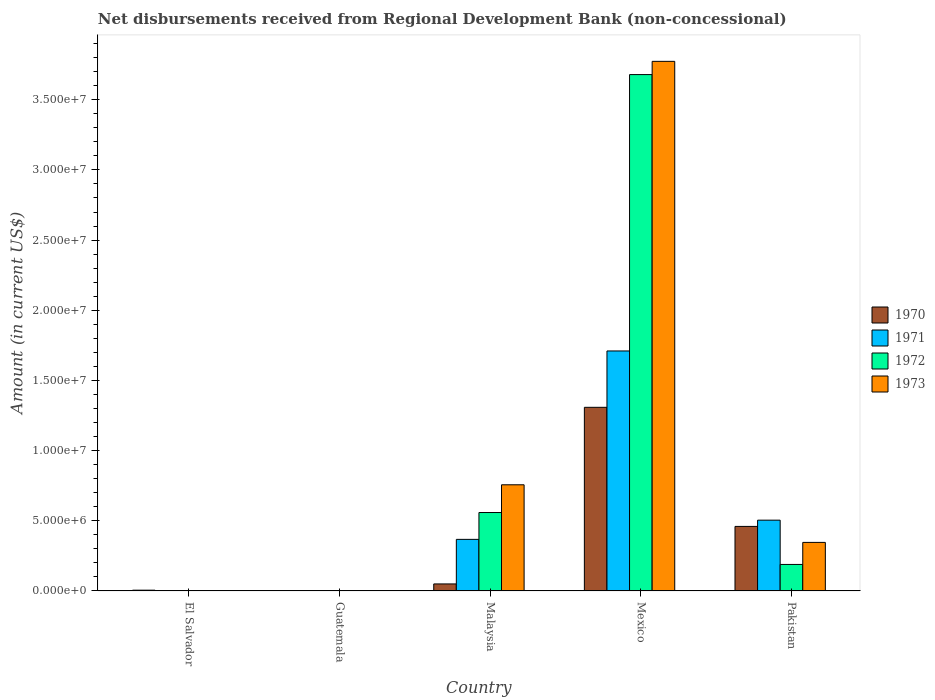Are the number of bars per tick equal to the number of legend labels?
Your answer should be very brief. No. Are the number of bars on each tick of the X-axis equal?
Provide a succinct answer. No. What is the label of the 3rd group of bars from the left?
Your answer should be very brief. Malaysia. What is the amount of disbursements received from Regional Development Bank in 1971 in Pakistan?
Your answer should be compact. 5.04e+06. Across all countries, what is the maximum amount of disbursements received from Regional Development Bank in 1973?
Offer a very short reply. 3.77e+07. Across all countries, what is the minimum amount of disbursements received from Regional Development Bank in 1971?
Make the answer very short. 0. In which country was the amount of disbursements received from Regional Development Bank in 1971 maximum?
Keep it short and to the point. Mexico. What is the total amount of disbursements received from Regional Development Bank in 1972 in the graph?
Offer a terse response. 4.43e+07. What is the difference between the amount of disbursements received from Regional Development Bank in 1970 in Malaysia and that in Mexico?
Ensure brevity in your answer.  -1.26e+07. What is the difference between the amount of disbursements received from Regional Development Bank in 1973 in Malaysia and the amount of disbursements received from Regional Development Bank in 1971 in Mexico?
Your answer should be compact. -9.54e+06. What is the average amount of disbursements received from Regional Development Bank in 1972 per country?
Your answer should be compact. 8.85e+06. What is the difference between the amount of disbursements received from Regional Development Bank of/in 1971 and amount of disbursements received from Regional Development Bank of/in 1973 in Pakistan?
Provide a succinct answer. 1.58e+06. In how many countries, is the amount of disbursements received from Regional Development Bank in 1973 greater than 12000000 US$?
Offer a very short reply. 1. What is the ratio of the amount of disbursements received from Regional Development Bank in 1971 in Malaysia to that in Mexico?
Offer a very short reply. 0.22. What is the difference between the highest and the second highest amount of disbursements received from Regional Development Bank in 1973?
Ensure brevity in your answer.  3.43e+07. What is the difference between the highest and the lowest amount of disbursements received from Regional Development Bank in 1973?
Ensure brevity in your answer.  3.77e+07. Is the sum of the amount of disbursements received from Regional Development Bank in 1973 in Malaysia and Pakistan greater than the maximum amount of disbursements received from Regional Development Bank in 1972 across all countries?
Make the answer very short. No. Is it the case that in every country, the sum of the amount of disbursements received from Regional Development Bank in 1973 and amount of disbursements received from Regional Development Bank in 1970 is greater than the sum of amount of disbursements received from Regional Development Bank in 1972 and amount of disbursements received from Regional Development Bank in 1971?
Offer a terse response. No. Is it the case that in every country, the sum of the amount of disbursements received from Regional Development Bank in 1970 and amount of disbursements received from Regional Development Bank in 1971 is greater than the amount of disbursements received from Regional Development Bank in 1972?
Offer a terse response. No. How many bars are there?
Keep it short and to the point. 13. How many countries are there in the graph?
Ensure brevity in your answer.  5. What is the difference between two consecutive major ticks on the Y-axis?
Provide a short and direct response. 5.00e+06. Does the graph contain grids?
Offer a terse response. No. Where does the legend appear in the graph?
Your answer should be compact. Center right. How many legend labels are there?
Offer a terse response. 4. What is the title of the graph?
Keep it short and to the point. Net disbursements received from Regional Development Bank (non-concessional). Does "2010" appear as one of the legend labels in the graph?
Ensure brevity in your answer.  No. What is the Amount (in current US$) of 1970 in El Salvador?
Offer a very short reply. 5.70e+04. What is the Amount (in current US$) of 1970 in Guatemala?
Make the answer very short. 0. What is the Amount (in current US$) in 1971 in Guatemala?
Provide a succinct answer. 0. What is the Amount (in current US$) in 1970 in Malaysia?
Your response must be concise. 5.02e+05. What is the Amount (in current US$) in 1971 in Malaysia?
Keep it short and to the point. 3.68e+06. What is the Amount (in current US$) of 1972 in Malaysia?
Make the answer very short. 5.59e+06. What is the Amount (in current US$) in 1973 in Malaysia?
Make the answer very short. 7.57e+06. What is the Amount (in current US$) of 1970 in Mexico?
Your response must be concise. 1.31e+07. What is the Amount (in current US$) of 1971 in Mexico?
Offer a very short reply. 1.71e+07. What is the Amount (in current US$) in 1972 in Mexico?
Give a very brief answer. 3.68e+07. What is the Amount (in current US$) of 1973 in Mexico?
Ensure brevity in your answer.  3.77e+07. What is the Amount (in current US$) in 1970 in Pakistan?
Your answer should be compact. 4.60e+06. What is the Amount (in current US$) of 1971 in Pakistan?
Ensure brevity in your answer.  5.04e+06. What is the Amount (in current US$) of 1972 in Pakistan?
Provide a succinct answer. 1.89e+06. What is the Amount (in current US$) in 1973 in Pakistan?
Offer a terse response. 3.46e+06. Across all countries, what is the maximum Amount (in current US$) of 1970?
Your answer should be compact. 1.31e+07. Across all countries, what is the maximum Amount (in current US$) of 1971?
Keep it short and to the point. 1.71e+07. Across all countries, what is the maximum Amount (in current US$) of 1972?
Keep it short and to the point. 3.68e+07. Across all countries, what is the maximum Amount (in current US$) in 1973?
Offer a terse response. 3.77e+07. Across all countries, what is the minimum Amount (in current US$) in 1971?
Your response must be concise. 0. What is the total Amount (in current US$) in 1970 in the graph?
Make the answer very short. 1.82e+07. What is the total Amount (in current US$) in 1971 in the graph?
Your answer should be compact. 2.58e+07. What is the total Amount (in current US$) of 1972 in the graph?
Provide a short and direct response. 4.43e+07. What is the total Amount (in current US$) of 1973 in the graph?
Ensure brevity in your answer.  4.88e+07. What is the difference between the Amount (in current US$) of 1970 in El Salvador and that in Malaysia?
Your response must be concise. -4.45e+05. What is the difference between the Amount (in current US$) in 1970 in El Salvador and that in Mexico?
Give a very brief answer. -1.30e+07. What is the difference between the Amount (in current US$) in 1970 in El Salvador and that in Pakistan?
Ensure brevity in your answer.  -4.54e+06. What is the difference between the Amount (in current US$) in 1970 in Malaysia and that in Mexico?
Ensure brevity in your answer.  -1.26e+07. What is the difference between the Amount (in current US$) of 1971 in Malaysia and that in Mexico?
Ensure brevity in your answer.  -1.34e+07. What is the difference between the Amount (in current US$) in 1972 in Malaysia and that in Mexico?
Provide a short and direct response. -3.12e+07. What is the difference between the Amount (in current US$) of 1973 in Malaysia and that in Mexico?
Ensure brevity in your answer.  -3.02e+07. What is the difference between the Amount (in current US$) of 1970 in Malaysia and that in Pakistan?
Your answer should be very brief. -4.10e+06. What is the difference between the Amount (in current US$) of 1971 in Malaysia and that in Pakistan?
Provide a short and direct response. -1.37e+06. What is the difference between the Amount (in current US$) of 1972 in Malaysia and that in Pakistan?
Offer a terse response. 3.70e+06. What is the difference between the Amount (in current US$) in 1973 in Malaysia and that in Pakistan?
Make the answer very short. 4.10e+06. What is the difference between the Amount (in current US$) in 1970 in Mexico and that in Pakistan?
Provide a short and direct response. 8.48e+06. What is the difference between the Amount (in current US$) in 1971 in Mexico and that in Pakistan?
Provide a succinct answer. 1.21e+07. What is the difference between the Amount (in current US$) in 1972 in Mexico and that in Pakistan?
Keep it short and to the point. 3.49e+07. What is the difference between the Amount (in current US$) of 1973 in Mexico and that in Pakistan?
Offer a very short reply. 3.43e+07. What is the difference between the Amount (in current US$) in 1970 in El Salvador and the Amount (in current US$) in 1971 in Malaysia?
Provide a short and direct response. -3.62e+06. What is the difference between the Amount (in current US$) in 1970 in El Salvador and the Amount (in current US$) in 1972 in Malaysia?
Your answer should be compact. -5.53e+06. What is the difference between the Amount (in current US$) in 1970 in El Salvador and the Amount (in current US$) in 1973 in Malaysia?
Offer a terse response. -7.51e+06. What is the difference between the Amount (in current US$) in 1970 in El Salvador and the Amount (in current US$) in 1971 in Mexico?
Ensure brevity in your answer.  -1.70e+07. What is the difference between the Amount (in current US$) of 1970 in El Salvador and the Amount (in current US$) of 1972 in Mexico?
Provide a short and direct response. -3.67e+07. What is the difference between the Amount (in current US$) of 1970 in El Salvador and the Amount (in current US$) of 1973 in Mexico?
Keep it short and to the point. -3.77e+07. What is the difference between the Amount (in current US$) in 1970 in El Salvador and the Amount (in current US$) in 1971 in Pakistan?
Ensure brevity in your answer.  -4.99e+06. What is the difference between the Amount (in current US$) of 1970 in El Salvador and the Amount (in current US$) of 1972 in Pakistan?
Provide a succinct answer. -1.83e+06. What is the difference between the Amount (in current US$) in 1970 in El Salvador and the Amount (in current US$) in 1973 in Pakistan?
Make the answer very short. -3.40e+06. What is the difference between the Amount (in current US$) in 1970 in Malaysia and the Amount (in current US$) in 1971 in Mexico?
Provide a short and direct response. -1.66e+07. What is the difference between the Amount (in current US$) in 1970 in Malaysia and the Amount (in current US$) in 1972 in Mexico?
Your answer should be compact. -3.63e+07. What is the difference between the Amount (in current US$) in 1970 in Malaysia and the Amount (in current US$) in 1973 in Mexico?
Provide a succinct answer. -3.72e+07. What is the difference between the Amount (in current US$) of 1971 in Malaysia and the Amount (in current US$) of 1972 in Mexico?
Your answer should be compact. -3.31e+07. What is the difference between the Amount (in current US$) of 1971 in Malaysia and the Amount (in current US$) of 1973 in Mexico?
Give a very brief answer. -3.41e+07. What is the difference between the Amount (in current US$) in 1972 in Malaysia and the Amount (in current US$) in 1973 in Mexico?
Offer a very short reply. -3.21e+07. What is the difference between the Amount (in current US$) in 1970 in Malaysia and the Amount (in current US$) in 1971 in Pakistan?
Provide a short and direct response. -4.54e+06. What is the difference between the Amount (in current US$) of 1970 in Malaysia and the Amount (in current US$) of 1972 in Pakistan?
Your answer should be compact. -1.39e+06. What is the difference between the Amount (in current US$) in 1970 in Malaysia and the Amount (in current US$) in 1973 in Pakistan?
Make the answer very short. -2.96e+06. What is the difference between the Amount (in current US$) of 1971 in Malaysia and the Amount (in current US$) of 1972 in Pakistan?
Provide a succinct answer. 1.79e+06. What is the difference between the Amount (in current US$) of 1971 in Malaysia and the Amount (in current US$) of 1973 in Pakistan?
Ensure brevity in your answer.  2.16e+05. What is the difference between the Amount (in current US$) of 1972 in Malaysia and the Amount (in current US$) of 1973 in Pakistan?
Your response must be concise. 2.13e+06. What is the difference between the Amount (in current US$) of 1970 in Mexico and the Amount (in current US$) of 1971 in Pakistan?
Make the answer very short. 8.04e+06. What is the difference between the Amount (in current US$) of 1970 in Mexico and the Amount (in current US$) of 1972 in Pakistan?
Offer a very short reply. 1.12e+07. What is the difference between the Amount (in current US$) of 1970 in Mexico and the Amount (in current US$) of 1973 in Pakistan?
Give a very brief answer. 9.62e+06. What is the difference between the Amount (in current US$) in 1971 in Mexico and the Amount (in current US$) in 1972 in Pakistan?
Make the answer very short. 1.52e+07. What is the difference between the Amount (in current US$) in 1971 in Mexico and the Amount (in current US$) in 1973 in Pakistan?
Your response must be concise. 1.36e+07. What is the difference between the Amount (in current US$) in 1972 in Mexico and the Amount (in current US$) in 1973 in Pakistan?
Give a very brief answer. 3.33e+07. What is the average Amount (in current US$) in 1970 per country?
Provide a short and direct response. 3.65e+06. What is the average Amount (in current US$) in 1971 per country?
Offer a very short reply. 5.16e+06. What is the average Amount (in current US$) of 1972 per country?
Your answer should be very brief. 8.85e+06. What is the average Amount (in current US$) in 1973 per country?
Give a very brief answer. 9.75e+06. What is the difference between the Amount (in current US$) of 1970 and Amount (in current US$) of 1971 in Malaysia?
Keep it short and to the point. -3.18e+06. What is the difference between the Amount (in current US$) in 1970 and Amount (in current US$) in 1972 in Malaysia?
Keep it short and to the point. -5.09e+06. What is the difference between the Amount (in current US$) in 1970 and Amount (in current US$) in 1973 in Malaysia?
Offer a terse response. -7.06e+06. What is the difference between the Amount (in current US$) in 1971 and Amount (in current US$) in 1972 in Malaysia?
Give a very brief answer. -1.91e+06. What is the difference between the Amount (in current US$) in 1971 and Amount (in current US$) in 1973 in Malaysia?
Give a very brief answer. -3.89e+06. What is the difference between the Amount (in current US$) of 1972 and Amount (in current US$) of 1973 in Malaysia?
Ensure brevity in your answer.  -1.98e+06. What is the difference between the Amount (in current US$) in 1970 and Amount (in current US$) in 1971 in Mexico?
Your response must be concise. -4.02e+06. What is the difference between the Amount (in current US$) in 1970 and Amount (in current US$) in 1972 in Mexico?
Your answer should be compact. -2.37e+07. What is the difference between the Amount (in current US$) of 1970 and Amount (in current US$) of 1973 in Mexico?
Offer a terse response. -2.46e+07. What is the difference between the Amount (in current US$) of 1971 and Amount (in current US$) of 1972 in Mexico?
Offer a terse response. -1.97e+07. What is the difference between the Amount (in current US$) of 1971 and Amount (in current US$) of 1973 in Mexico?
Make the answer very short. -2.06e+07. What is the difference between the Amount (in current US$) of 1972 and Amount (in current US$) of 1973 in Mexico?
Keep it short and to the point. -9.43e+05. What is the difference between the Amount (in current US$) of 1970 and Amount (in current US$) of 1971 in Pakistan?
Provide a succinct answer. -4.45e+05. What is the difference between the Amount (in current US$) of 1970 and Amount (in current US$) of 1972 in Pakistan?
Offer a terse response. 2.71e+06. What is the difference between the Amount (in current US$) in 1970 and Amount (in current US$) in 1973 in Pakistan?
Offer a terse response. 1.14e+06. What is the difference between the Amount (in current US$) in 1971 and Amount (in current US$) in 1972 in Pakistan?
Your response must be concise. 3.16e+06. What is the difference between the Amount (in current US$) in 1971 and Amount (in current US$) in 1973 in Pakistan?
Ensure brevity in your answer.  1.58e+06. What is the difference between the Amount (in current US$) in 1972 and Amount (in current US$) in 1973 in Pakistan?
Offer a terse response. -1.57e+06. What is the ratio of the Amount (in current US$) in 1970 in El Salvador to that in Malaysia?
Your answer should be very brief. 0.11. What is the ratio of the Amount (in current US$) in 1970 in El Salvador to that in Mexico?
Give a very brief answer. 0. What is the ratio of the Amount (in current US$) of 1970 in El Salvador to that in Pakistan?
Provide a succinct answer. 0.01. What is the ratio of the Amount (in current US$) of 1970 in Malaysia to that in Mexico?
Keep it short and to the point. 0.04. What is the ratio of the Amount (in current US$) in 1971 in Malaysia to that in Mexico?
Your answer should be very brief. 0.21. What is the ratio of the Amount (in current US$) of 1972 in Malaysia to that in Mexico?
Provide a succinct answer. 0.15. What is the ratio of the Amount (in current US$) in 1973 in Malaysia to that in Mexico?
Your answer should be very brief. 0.2. What is the ratio of the Amount (in current US$) of 1970 in Malaysia to that in Pakistan?
Make the answer very short. 0.11. What is the ratio of the Amount (in current US$) of 1971 in Malaysia to that in Pakistan?
Your answer should be compact. 0.73. What is the ratio of the Amount (in current US$) in 1972 in Malaysia to that in Pakistan?
Provide a succinct answer. 2.96. What is the ratio of the Amount (in current US$) in 1973 in Malaysia to that in Pakistan?
Ensure brevity in your answer.  2.19. What is the ratio of the Amount (in current US$) in 1970 in Mexico to that in Pakistan?
Provide a succinct answer. 2.84. What is the ratio of the Amount (in current US$) of 1971 in Mexico to that in Pakistan?
Ensure brevity in your answer.  3.39. What is the ratio of the Amount (in current US$) in 1972 in Mexico to that in Pakistan?
Your answer should be very brief. 19.47. What is the ratio of the Amount (in current US$) of 1973 in Mexico to that in Pakistan?
Give a very brief answer. 10.9. What is the difference between the highest and the second highest Amount (in current US$) of 1970?
Offer a terse response. 8.48e+06. What is the difference between the highest and the second highest Amount (in current US$) of 1971?
Ensure brevity in your answer.  1.21e+07. What is the difference between the highest and the second highest Amount (in current US$) in 1972?
Provide a short and direct response. 3.12e+07. What is the difference between the highest and the second highest Amount (in current US$) of 1973?
Provide a succinct answer. 3.02e+07. What is the difference between the highest and the lowest Amount (in current US$) of 1970?
Provide a succinct answer. 1.31e+07. What is the difference between the highest and the lowest Amount (in current US$) in 1971?
Provide a succinct answer. 1.71e+07. What is the difference between the highest and the lowest Amount (in current US$) in 1972?
Provide a succinct answer. 3.68e+07. What is the difference between the highest and the lowest Amount (in current US$) in 1973?
Your answer should be very brief. 3.77e+07. 